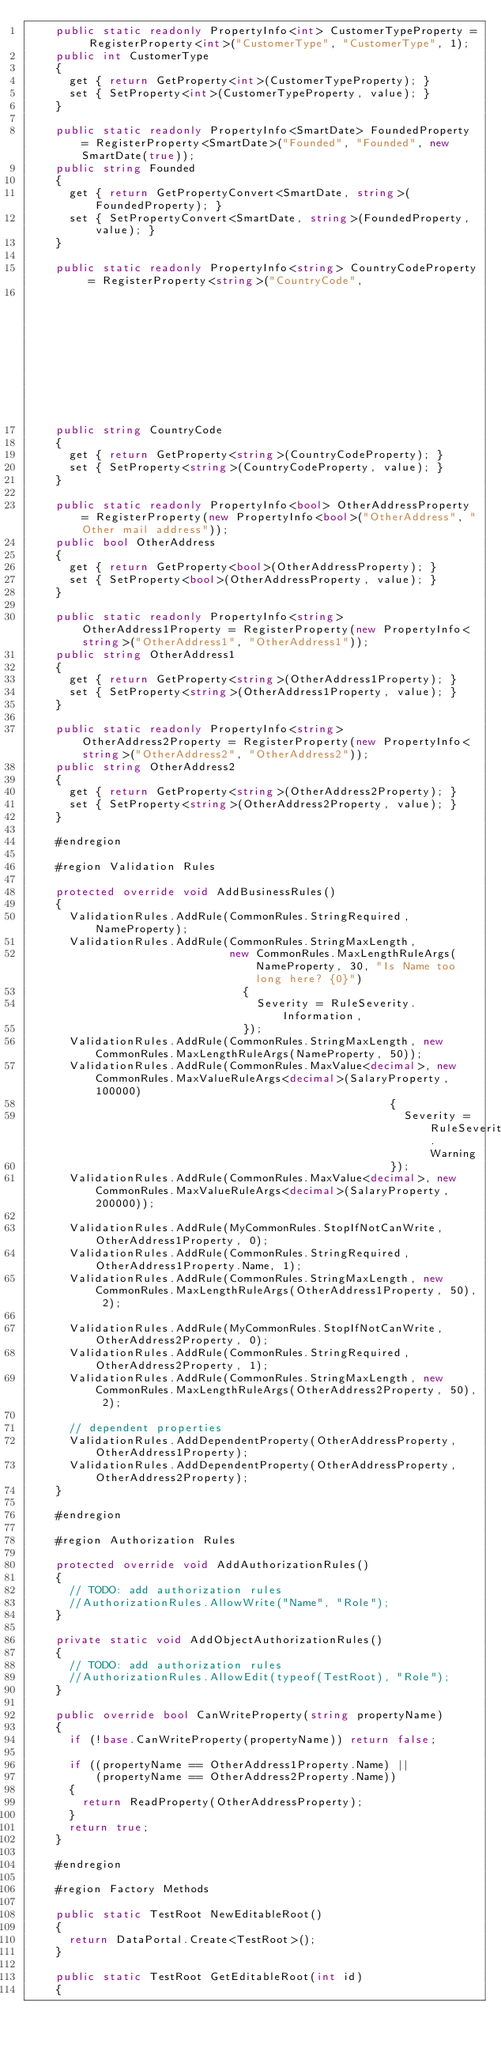<code> <loc_0><loc_0><loc_500><loc_500><_C#_>    public static readonly PropertyInfo<int> CustomerTypeProperty = RegisterProperty<int>("CustomerType", "CustomerType", 1);
    public int CustomerType
    {
      get { return GetProperty<int>(CustomerTypeProperty); }
      set { SetProperty<int>(CustomerTypeProperty, value); }
    }

    public static readonly PropertyInfo<SmartDate> FoundedProperty = RegisterProperty<SmartDate>("Founded", "Founded", new SmartDate(true));
    public string Founded
    {
      get { return GetPropertyConvert<SmartDate, string>(FoundedProperty); }
      set { SetPropertyConvert<SmartDate, string>(FoundedProperty, value); }
    }

    public static readonly PropertyInfo<string> CountryCodeProperty = RegisterProperty<string>("CountryCode",
                                                                                               "CountryCode", "US");
    public string CountryCode
    {
      get { return GetProperty<string>(CountryCodeProperty); }
      set { SetProperty<string>(CountryCodeProperty, value); }
    }

    public static readonly PropertyInfo<bool> OtherAddressProperty = RegisterProperty(new PropertyInfo<bool>("OtherAddress", "Other mail address"));
    public bool OtherAddress
    {
      get { return GetProperty<bool>(OtherAddressProperty); }
      set { SetProperty<bool>(OtherAddressProperty, value); }
    }

    public static readonly PropertyInfo<string> OtherAddress1Property = RegisterProperty(new PropertyInfo<string>("OtherAddress1", "OtherAddress1"));
    public string OtherAddress1
    {
      get { return GetProperty<string>(OtherAddress1Property); }
      set { SetProperty<string>(OtherAddress1Property, value); }
    }

    public static readonly PropertyInfo<string> OtherAddress2Property = RegisterProperty(new PropertyInfo<string>("OtherAddress2", "OtherAddress2"));
    public string OtherAddress2
    {
      get { return GetProperty<string>(OtherAddress2Property); }
      set { SetProperty<string>(OtherAddress2Property, value); }
    }

    #endregion

    #region Validation Rules

    protected override void AddBusinessRules()
    {
      ValidationRules.AddRule(CommonRules.StringRequired, NameProperty);
      ValidationRules.AddRule(CommonRules.StringMaxLength,
                              new CommonRules.MaxLengthRuleArgs(NameProperty, 30, "Is Name too long here? {0}")
                                {
                                  Severity = RuleSeverity.Information,
                                });
      ValidationRules.AddRule(CommonRules.StringMaxLength, new CommonRules.MaxLengthRuleArgs(NameProperty, 50));
      ValidationRules.AddRule(CommonRules.MaxValue<decimal>, new CommonRules.MaxValueRuleArgs<decimal>(SalaryProperty, 100000)
                                                      {
                                                        Severity = RuleSeverity.Warning
                                                      });
      ValidationRules.AddRule(CommonRules.MaxValue<decimal>, new CommonRules.MaxValueRuleArgs<decimal>(SalaryProperty, 200000));

      ValidationRules.AddRule(MyCommonRules.StopIfNotCanWrite, OtherAddress1Property, 0);
      ValidationRules.AddRule(CommonRules.StringRequired, OtherAddress1Property.Name, 1);
      ValidationRules.AddRule(CommonRules.StringMaxLength, new CommonRules.MaxLengthRuleArgs(OtherAddress1Property, 50), 2);

      ValidationRules.AddRule(MyCommonRules.StopIfNotCanWrite, OtherAddress2Property, 0);
      ValidationRules.AddRule(CommonRules.StringRequired, OtherAddress2Property, 1);
      ValidationRules.AddRule(CommonRules.StringMaxLength, new CommonRules.MaxLengthRuleArgs(OtherAddress2Property, 50), 2);

      // dependent properties 
      ValidationRules.AddDependentProperty(OtherAddressProperty, OtherAddress1Property);
      ValidationRules.AddDependentProperty(OtherAddressProperty, OtherAddress2Property);
    }

    #endregion

    #region Authorization Rules

    protected override void AddAuthorizationRules()
    {
      // TODO: add authorization rules
      //AuthorizationRules.AllowWrite("Name", "Role");
    }

    private static void AddObjectAuthorizationRules()
    {
      // TODO: add authorization rules
      //AuthorizationRules.AllowEdit(typeof(TestRoot), "Role");
    }

    public override bool CanWriteProperty(string propertyName)
    {
      if (!base.CanWriteProperty(propertyName)) return false;

      if ((propertyName == OtherAddress1Property.Name) ||
          (propertyName == OtherAddress2Property.Name))
      {
        return ReadProperty(OtherAddressProperty);
      }
      return true; 
    }

    #endregion

    #region Factory Methods

    public static TestRoot NewEditableRoot()
    {
      return DataPortal.Create<TestRoot>();
    }

    public static TestRoot GetEditableRoot(int id)
    {</code> 